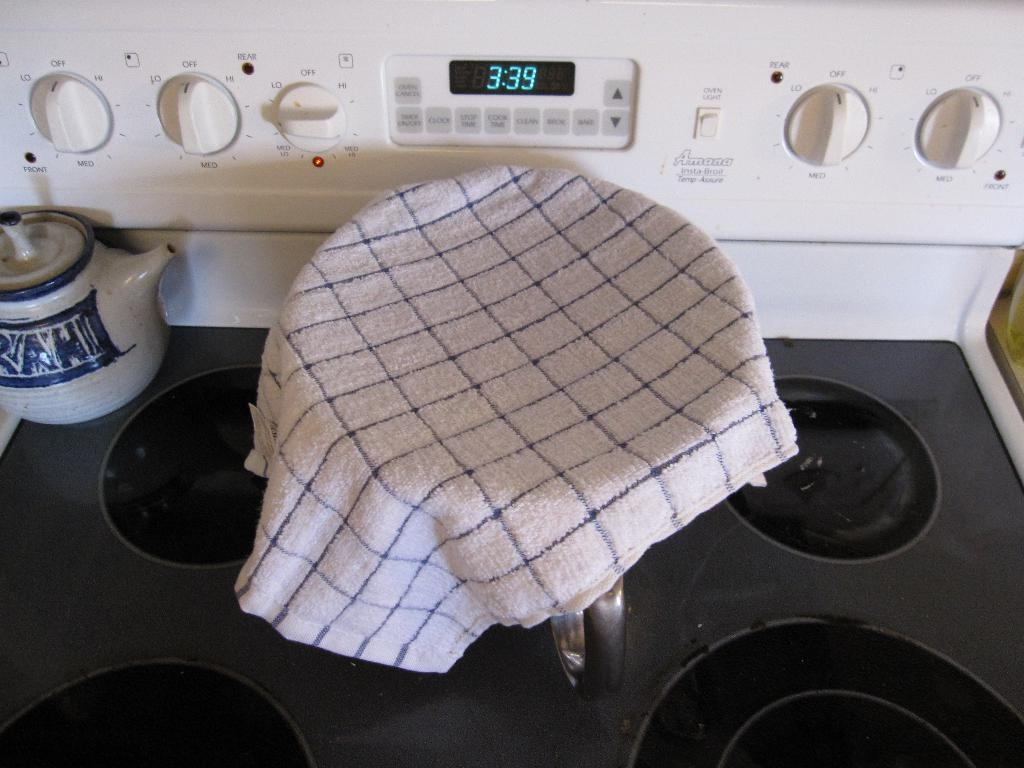<image>
Create a compact narrative representing the image presented. the time on the clock reads 3:39 on it 